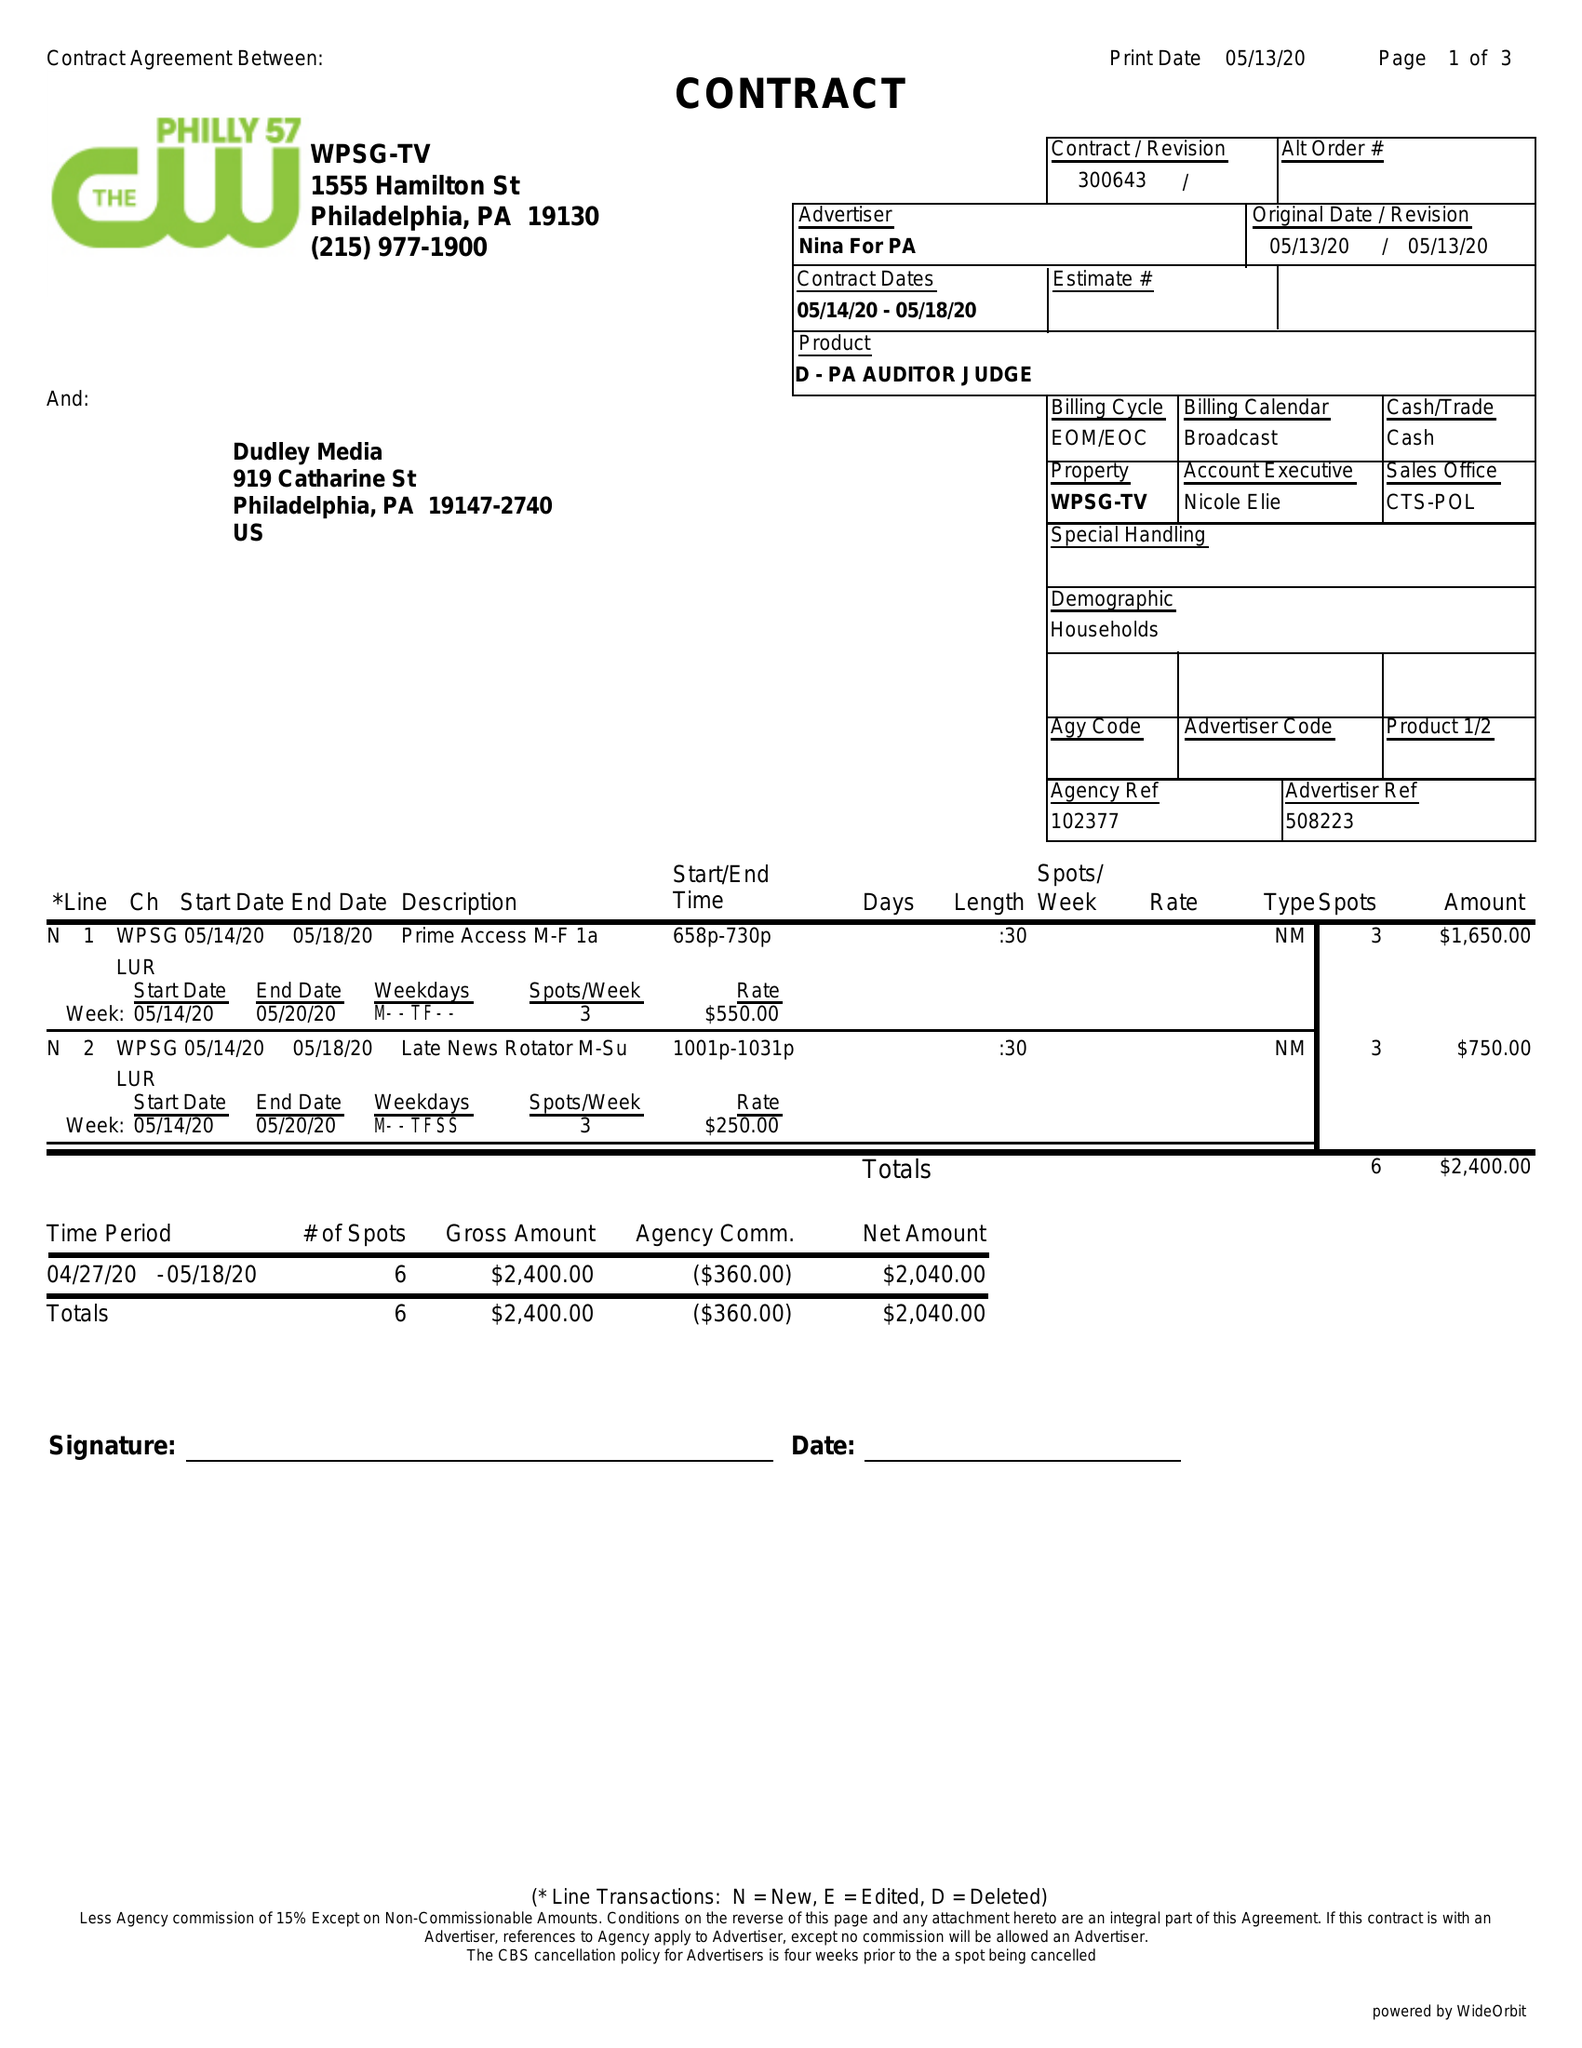What is the value for the gross_amount?
Answer the question using a single word or phrase. 2400.00 